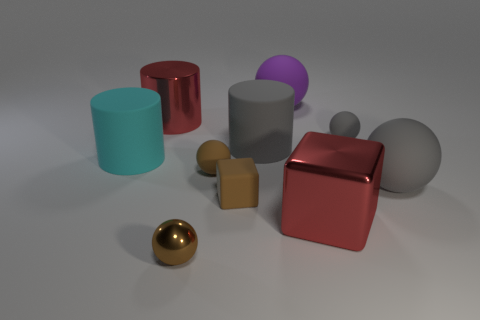Is the shape of the small thing that is right of the red metal cube the same as  the big cyan matte thing?
Your answer should be compact. No. How many small objects are the same material as the gray cylinder?
Make the answer very short. 3. What number of objects are either large rubber objects left of the small gray matte thing or tiny brown metallic blocks?
Make the answer very short. 3. The brown cube has what size?
Provide a succinct answer. Small. The large red object to the right of the big cylinder that is on the right side of the tiny rubber block is made of what material?
Ensure brevity in your answer.  Metal. There is a metallic object that is behind the cyan thing; is it the same size as the big shiny block?
Provide a short and direct response. Yes. Is there a big metal cylinder of the same color as the small metallic ball?
Provide a short and direct response. No. What number of things are tiny rubber objects that are to the right of the big metallic block or things that are in front of the rubber cube?
Your response must be concise. 3. Is the small rubber cube the same color as the large cube?
Offer a very short reply. No. There is a tiny ball that is the same color as the tiny shiny thing; what is it made of?
Your answer should be compact. Rubber. 